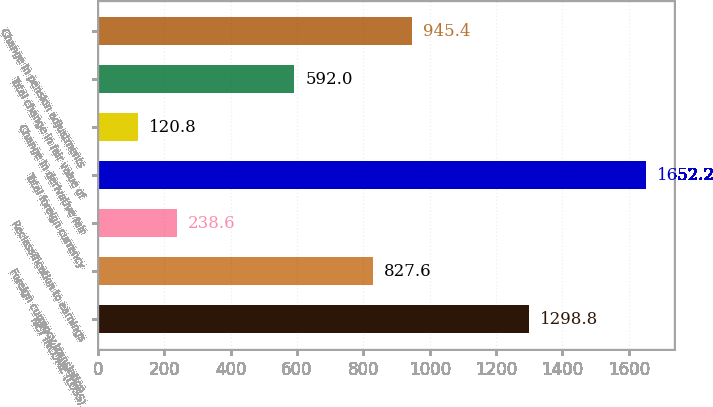Convert chart to OTSL. <chart><loc_0><loc_0><loc_500><loc_500><bar_chart><fcel>NET INCOME (LOSS)<fcel>Foreign currency translation<fcel>Reclassification to earnings<fcel>Total foreign currency<fcel>Change in derivative fair<fcel>Total change in fair value of<fcel>Change in pension adjustments<nl><fcel>1298.8<fcel>827.6<fcel>238.6<fcel>1652.2<fcel>120.8<fcel>592<fcel>945.4<nl></chart> 